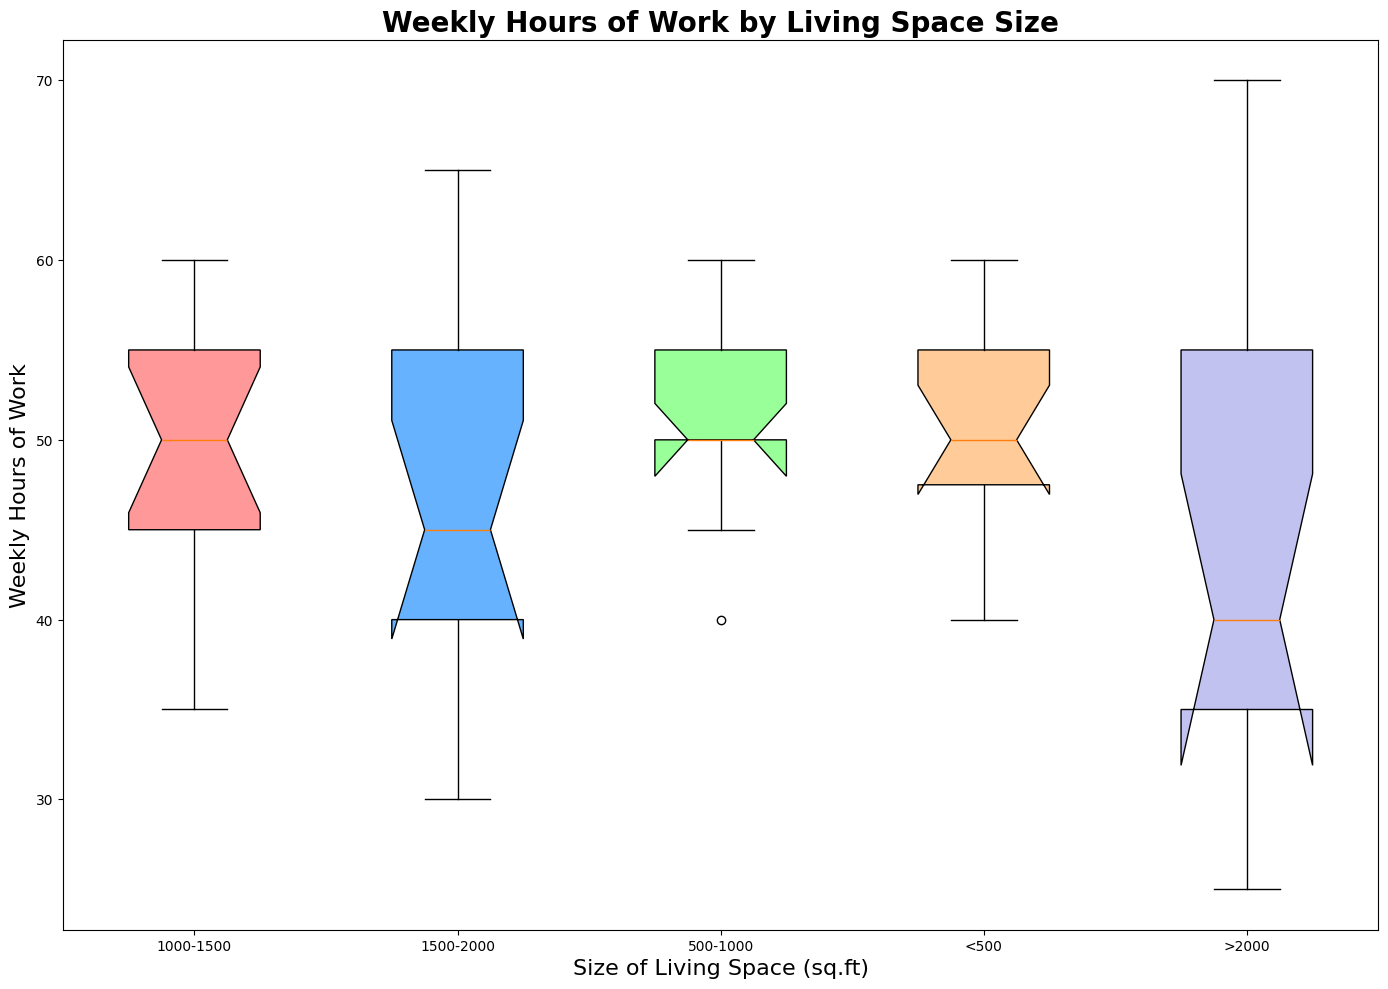How does the median weekly hours of work for <500 sq.ft compare to >2000 sq.ft? The median can be observed at the center of each box plot. For <500 sq.ft, the median weekly hours of work appears higher compared to >2000 sq.ft, indicating that people living in smaller spaces tend to work more hours.
Answer: The median weekly hours of work is higher for <500 sq.ft than >2000 sq.ft Which living space size has the widest interquartile range (IQR) for weekly hours of work? The IQR can be identified as the distance between the lower and upper edges of the box (25th percentile to 75th percentile). The size category 1000-1500 sq.ft has the widest IQR, suggesting the greatest variability in weekly hours of work among people living in that space size.
Answer: 1000-1500 sq.ft Do people living in <500 sq.ft work more hours compared to people living in 500-1000 sq.ft? By comparing the box plots for <500 sq.ft and 500-1000 sq.ft, we see that the median of <500 sq.ft is slightly lower. This suggests that people in <500 sq.ft tend to work less than those in 500-1000 sq.ft.
Answer: No Is the variation in weekly hours of work larger for people living in <500 sq.ft or >2000 sq.ft? The variation can be assessed by comparing the lengths of the whiskers and the range of each box plot. The box plot for people living in >2000 sq.ft has longer whiskers, indicating greater variation in weekly hours of work compared to those living in <500 sq.ft.
Answer: >2000 sq.ft Which living space size category is associated with the least median weekly hours of work? Observing the medians marked inside each box, the living space size category >2000 sq.ft has the lowest median weekly hours of work.
Answer: >2000 sq.ft What is the range of weekly hours of work for people living in 1500-2000 sq.ft? The range can be determined by the difference between the highest and lowest whisker points for the 1500-2000 sq.ft category. This range indicates that people living in this space category have varying work hours.
Answer: 30 to 70 hours How do weekly work hours change with increasing living space size? Observing the medians of the box plots, there is a general trend that indicates a decrease in weekly work hours as the size of living space increases from <500 sq.ft to >2000 sq.ft.
Answer: Decrease Which living space size has the smallest interquartile range (IQR) for weekly hours of work? The IQR is the distance between the 25th and 75th percentiles. The living space size category of >2000 sq.ft has the smallest IQR, suggesting more consistency in weekly work hours.
Answer: >2000 sq.ft 